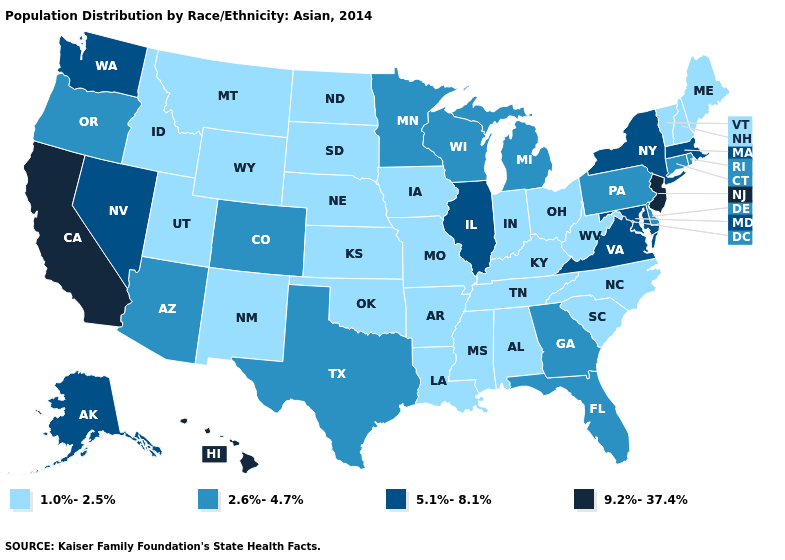Does Wyoming have a lower value than Florida?
Concise answer only. Yes. Name the states that have a value in the range 9.2%-37.4%?
Answer briefly. California, Hawaii, New Jersey. Does Oregon have the lowest value in the West?
Be succinct. No. Name the states that have a value in the range 5.1%-8.1%?
Quick response, please. Alaska, Illinois, Maryland, Massachusetts, Nevada, New York, Virginia, Washington. Which states hav the highest value in the Northeast?
Keep it brief. New Jersey. What is the lowest value in the West?
Concise answer only. 1.0%-2.5%. What is the lowest value in the Northeast?
Quick response, please. 1.0%-2.5%. Does the first symbol in the legend represent the smallest category?
Keep it brief. Yes. Name the states that have a value in the range 1.0%-2.5%?
Give a very brief answer. Alabama, Arkansas, Idaho, Indiana, Iowa, Kansas, Kentucky, Louisiana, Maine, Mississippi, Missouri, Montana, Nebraska, New Hampshire, New Mexico, North Carolina, North Dakota, Ohio, Oklahoma, South Carolina, South Dakota, Tennessee, Utah, Vermont, West Virginia, Wyoming. Does Oklahoma have the same value as Oregon?
Keep it brief. No. Name the states that have a value in the range 2.6%-4.7%?
Write a very short answer. Arizona, Colorado, Connecticut, Delaware, Florida, Georgia, Michigan, Minnesota, Oregon, Pennsylvania, Rhode Island, Texas, Wisconsin. What is the value of Texas?
Give a very brief answer. 2.6%-4.7%. Name the states that have a value in the range 1.0%-2.5%?
Answer briefly. Alabama, Arkansas, Idaho, Indiana, Iowa, Kansas, Kentucky, Louisiana, Maine, Mississippi, Missouri, Montana, Nebraska, New Hampshire, New Mexico, North Carolina, North Dakota, Ohio, Oklahoma, South Carolina, South Dakota, Tennessee, Utah, Vermont, West Virginia, Wyoming. What is the value of South Carolina?
Answer briefly. 1.0%-2.5%. Name the states that have a value in the range 9.2%-37.4%?
Answer briefly. California, Hawaii, New Jersey. 